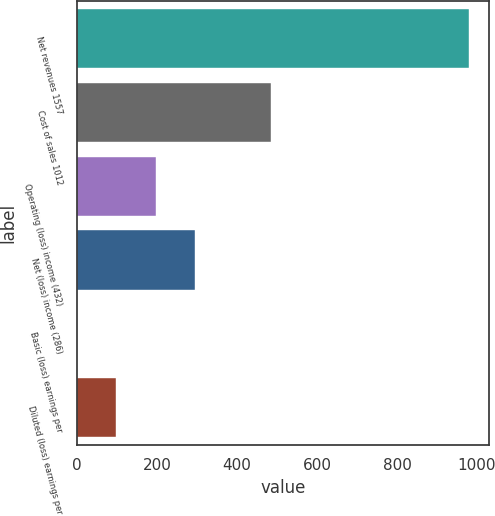Convert chart. <chart><loc_0><loc_0><loc_500><loc_500><bar_chart><fcel>Net revenues 1557<fcel>Cost of sales 1012<fcel>Operating (loss) income (432)<fcel>Net (loss) income (286)<fcel>Basic (loss) earnings per<fcel>Diluted (loss) earnings per<nl><fcel>981<fcel>484<fcel>196.32<fcel>294.41<fcel>0.14<fcel>98.23<nl></chart> 